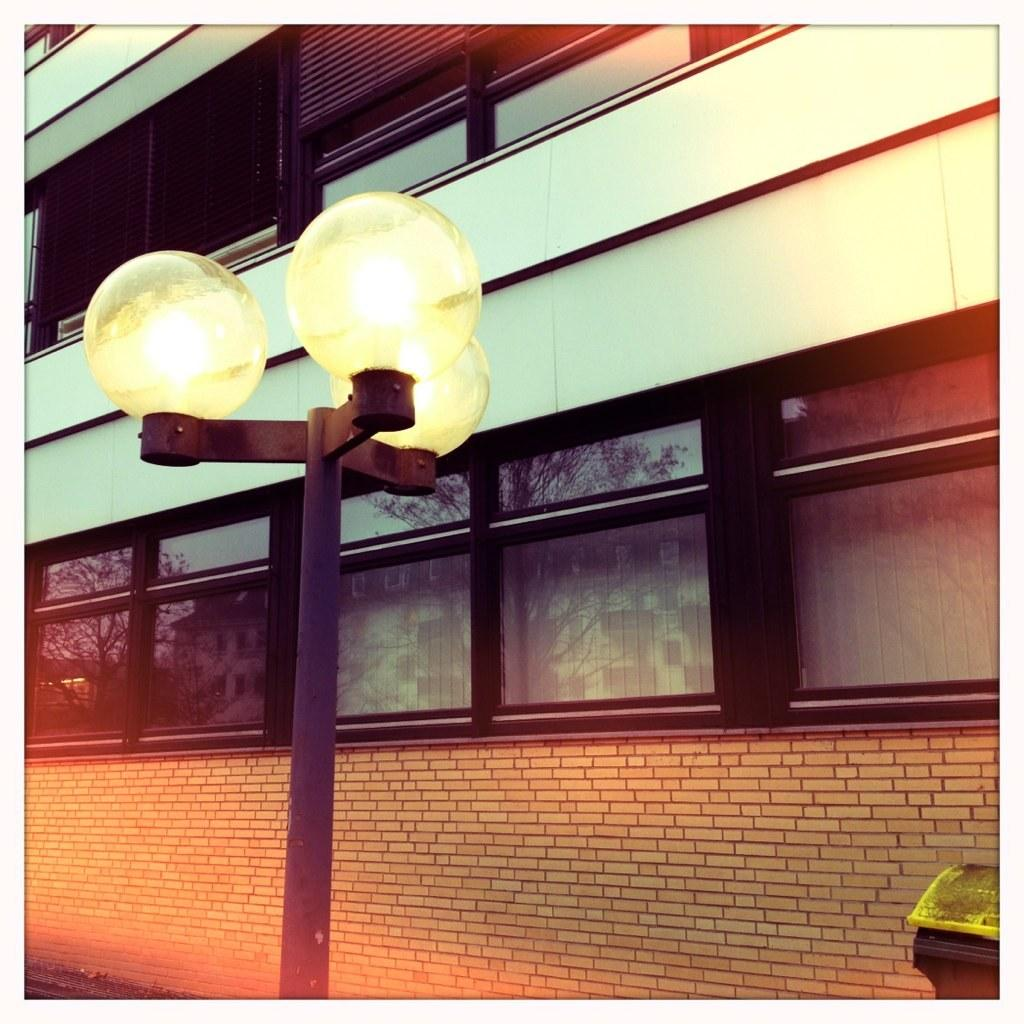What is located in the foreground of the image? There are three lights placed on a pole in the foreground of the image. What can be seen in the background of the image? There is a building with multiple windows in the background of the image. Are there any other objects visible in the background? Yes, there is a trash bin in the background of the image. How many toes can be seen on the brother's foot in the image? There is no brother or foot present in the image; it features three lights on a pole, a building with windows, and a trash bin. 